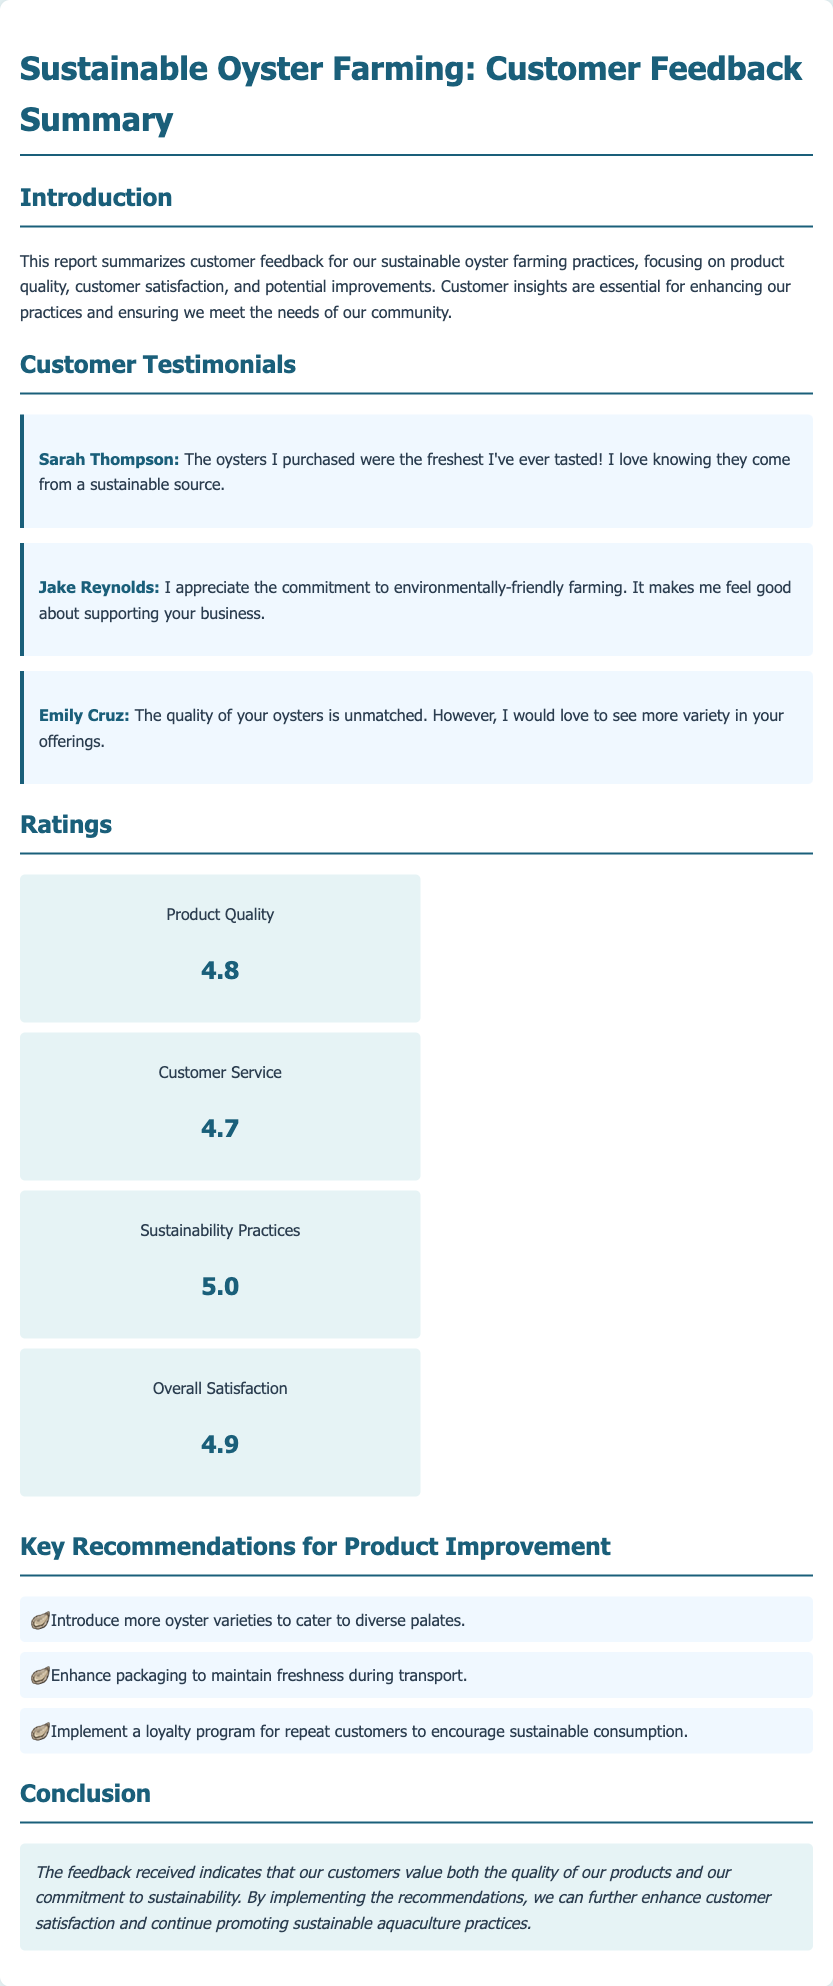What is the title of the report? The title is stated in the header of the document, which summarizes the focus on customer feedback for sustainable oyster farming.
Answer: Sustainable Oyster Farming: Customer Feedback Summary Who provided the testimonial about the freshest oysters? This information can be found in the customer testimonials section, where each testimonial is attributed to a specific person.
Answer: Sarah Thompson What rating did sustainability practices receive? The ratings section provides specific scores for various categories, including sustainability practices.
Answer: 5.0 What key recommendation is given for improving product offerings? The recommendations for product improvement are outlined in a bulleted list.
Answer: Introduce more oyster varieties to cater to diverse palates What is the overall satisfaction rating? This value is included in the ratings section which summarizes customer feedback on overall satisfaction.
Answer: 4.9 What does Emily Cruz indicate about the variety of offerings? Emily Cruz's testimonial mentions her desire for improvements in the variety offered.
Answer: More variety in your offerings 